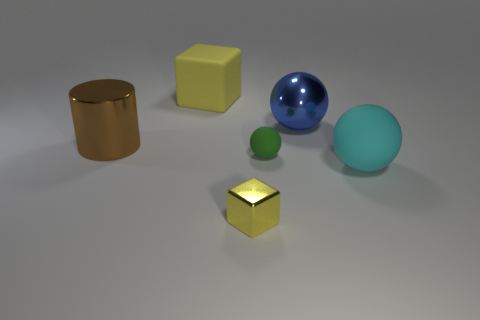Add 1 small yellow metallic cylinders. How many objects exist? 7 Subtract all cyan spheres. How many spheres are left? 2 Subtract all cylinders. How many objects are left? 5 Subtract 1 cylinders. How many cylinders are left? 0 Add 6 big rubber objects. How many big rubber objects are left? 8 Add 1 large metallic cylinders. How many large metallic cylinders exist? 2 Subtract all cyan spheres. How many spheres are left? 2 Subtract 1 green balls. How many objects are left? 5 Subtract all brown blocks. Subtract all gray spheres. How many blocks are left? 2 Subtract all purple cylinders. How many blue balls are left? 1 